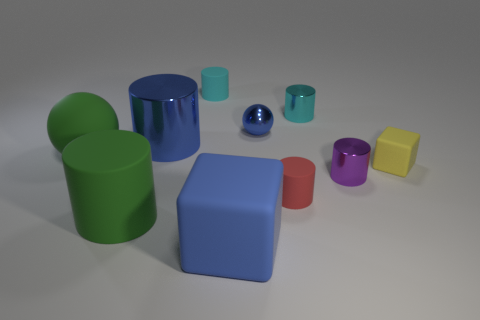There is a small cyan cylinder that is in front of the tiny cyan thing that is on the left side of the small blue shiny ball; how many red matte cylinders are in front of it?
Your answer should be compact. 1. There is a blue thing that is both behind the small red cylinder and to the right of the blue metal cylinder; what is it made of?
Your response must be concise. Metal. Is the material of the blue ball the same as the small yellow cube behind the tiny red object?
Provide a succinct answer. No. Is the number of big rubber cylinders that are to the left of the small purple shiny cylinder greater than the number of large green matte things that are behind the large green rubber ball?
Provide a short and direct response. Yes. What shape is the tiny red thing?
Your answer should be very brief. Cylinder. Is the material of the cube in front of the small yellow matte thing the same as the large cylinder in front of the small purple metallic thing?
Offer a very short reply. Yes. There is a small cyan thing to the right of the large blue rubber object; what shape is it?
Provide a succinct answer. Cylinder. The green thing that is the same shape as the purple metal object is what size?
Offer a terse response. Large. Do the small ball and the big sphere have the same color?
Your response must be concise. No. Are there any other things that are the same shape as the big blue rubber thing?
Provide a short and direct response. Yes. 